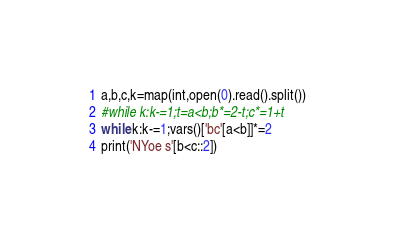Convert code to text. <code><loc_0><loc_0><loc_500><loc_500><_Python_>a,b,c,k=map(int,open(0).read().split())
#while k:k-=1;t=a<b;b*=2-t;c*=1+t
while k:k-=1;vars()['bc'[a<b]]*=2
print('NYoe s'[b<c::2])</code> 